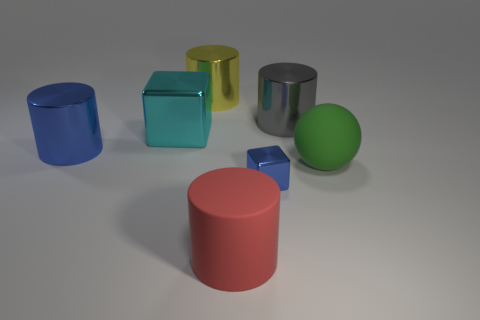Are there any other things that have the same size as the blue shiny block?
Make the answer very short. No. How big is the object that is both on the right side of the blue metal cube and left of the large green rubber sphere?
Provide a succinct answer. Large. Does the blue block have the same size as the gray shiny cylinder?
Make the answer very short. No. Is the color of the large cylinder behind the gray thing the same as the tiny shiny thing?
Make the answer very short. No. How many green spheres are in front of the red matte cylinder?
Make the answer very short. 0. Are there more big green matte things than tiny yellow metal things?
Your answer should be compact. Yes. There is a shiny object that is both on the right side of the red matte cylinder and behind the big cyan block; what shape is it?
Your answer should be compact. Cylinder. Is there a big blue matte sphere?
Your answer should be very brief. No. What material is the big gray object that is the same shape as the red matte object?
Make the answer very short. Metal. What is the shape of the blue object that is behind the blue metal object that is in front of the matte object that is on the right side of the gray metal cylinder?
Provide a short and direct response. Cylinder. 